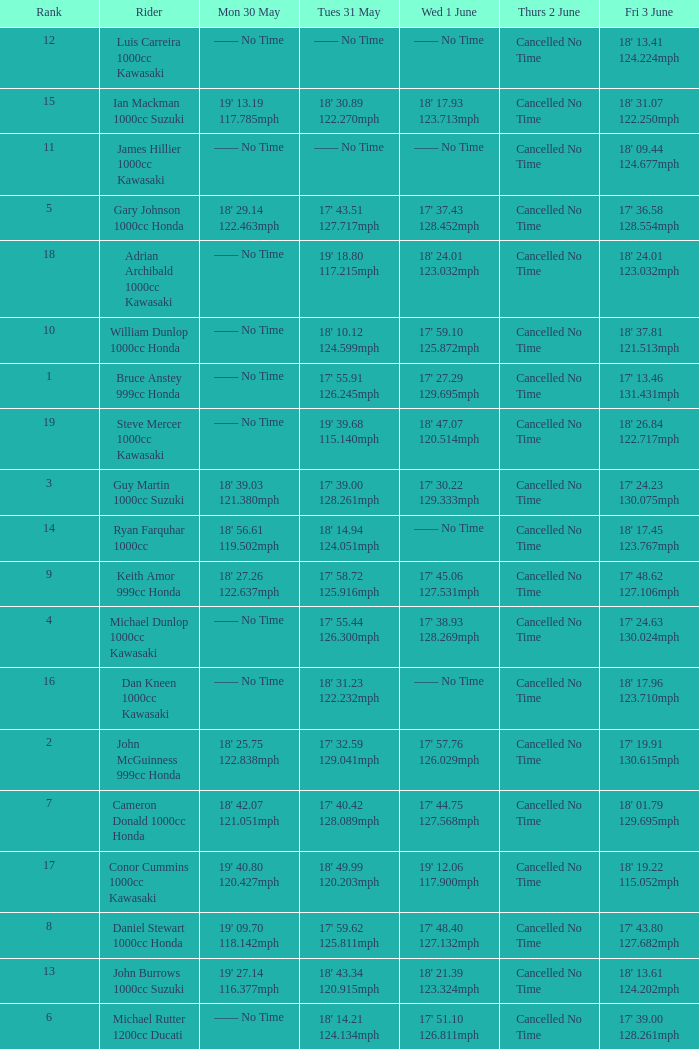What is the Fri 3 June time for the rider whose Tues 31 May time was 19' 18.80 117.215mph? 18' 24.01 123.032mph. 